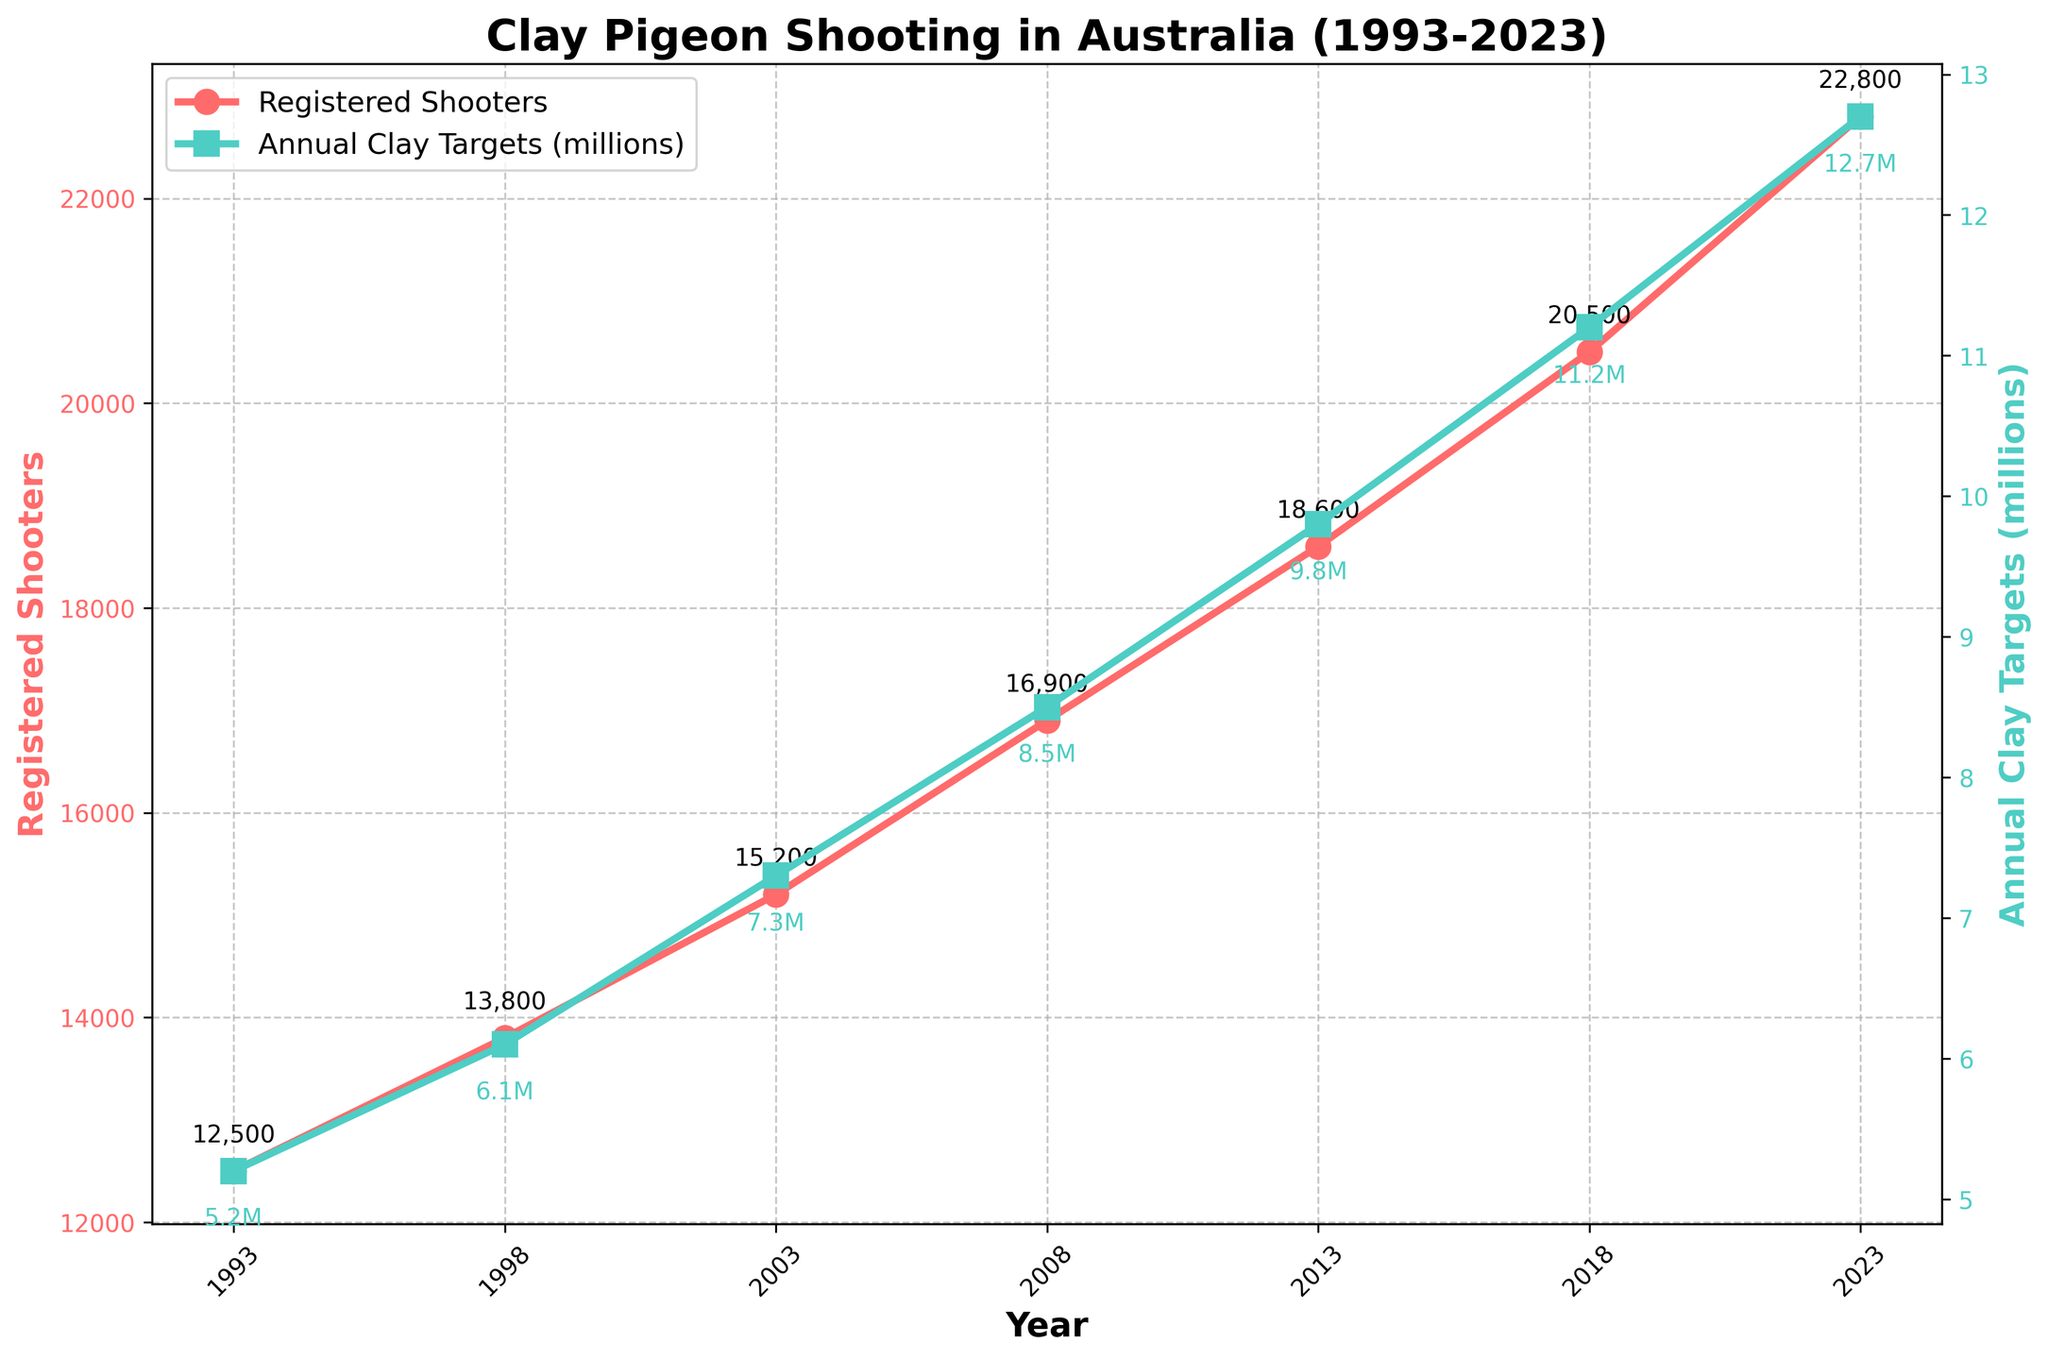What is the trend in the number of registered shooters from 1993 to 2023? To find the trend, look at the line for "Registered Shooters" and observe the general direction of the line from 1993 to 2023. The line shows a consistent upward trend.
Answer: Upward trend Which year had the highest registered shooters, and how many were there? Identify the peak of the "Registered Shooters" line. The highest point occurs in 2023, with 22,800 registered shooters.
Answer: 2023, 22,800 By how much did the number of registered shooters increase from 1993 to 2023? Subtract the number of registered shooters in 1993 (12,500) from the number in 2023 (22,800). 22,800 - 12,500 = 10,300.
Answer: 10,300 What color represents the "Annual Clay Targets Thrown (millions)" line in the chart? Look at the chart legend to identify the color used for the "Annual Clay Targets Thrown (millions)" line. The line is represented in green.
Answer: Green How do the trends in "Registered Shooters" and "Annual Clay Targets Thrown (millions)" compare over the years? Observe both lines: the "Registered Shooters" line (red) and the "Annual Clay Targets Thrown (millions)" line (green). Both lines show an upward trend over the years, indicating that both registered shooters and annual clay targets thrown have increased consistently.
Answer: Both increased What is the difference in the number of registered shooters between 2003 and 2018? To find the difference, subtract the number of registered shooters in 2003 (15,200) from the number in 2018 (20,500). 20,500 - 15,200 = 5,300.
Answer: 5,300 Which metric increased more steeply from 1993 to 2023, registered shooters or annual clay targets thrown (millions)? Compare the slopes of the two lines. The steeper the slope, the more rapid the increase. The line for "Annual Clay Targets Thrown (millions)" appears steeper at certain intervals, indicating a steeper increase.
Answer: Annual Clay Targets Thrown (millions) What is the average number of registered shooters between 1993 and 2023? Add all the values for "Registered Shooters" from 1993 to 2023 and divide by the number of years: (12500 + 13800 + 15200 + 16900 + 18600 + 20500 + 22800) / 7 = 17,471.43
Answer: 17,471.43 Which year saw the highest increase in the "Annual Clay Targets Thrown (millions)" compared to the previous five years? Calculate the differences between each year and compare. From 2018 to 2023, the increase is 12.7 - 11.2 = 1.5, which is the highest compared to the other intervals.
Answer: 2023 During which period did the "Registered Shooters" see the most significant growth, based on the slope of the line? Identify the steepest segment of the "Registered Shooters" line. The period between 2018 and 2023 shows the most significant growth, with a steep increase from 20,500 to 22,800.
Answer: 2018 to 2023 